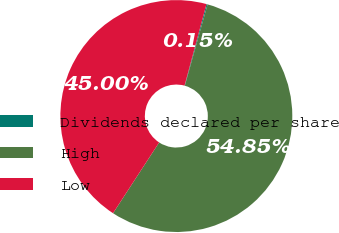Convert chart. <chart><loc_0><loc_0><loc_500><loc_500><pie_chart><fcel>Dividends declared per share<fcel>High<fcel>Low<nl><fcel>0.15%<fcel>54.85%<fcel>45.0%<nl></chart> 